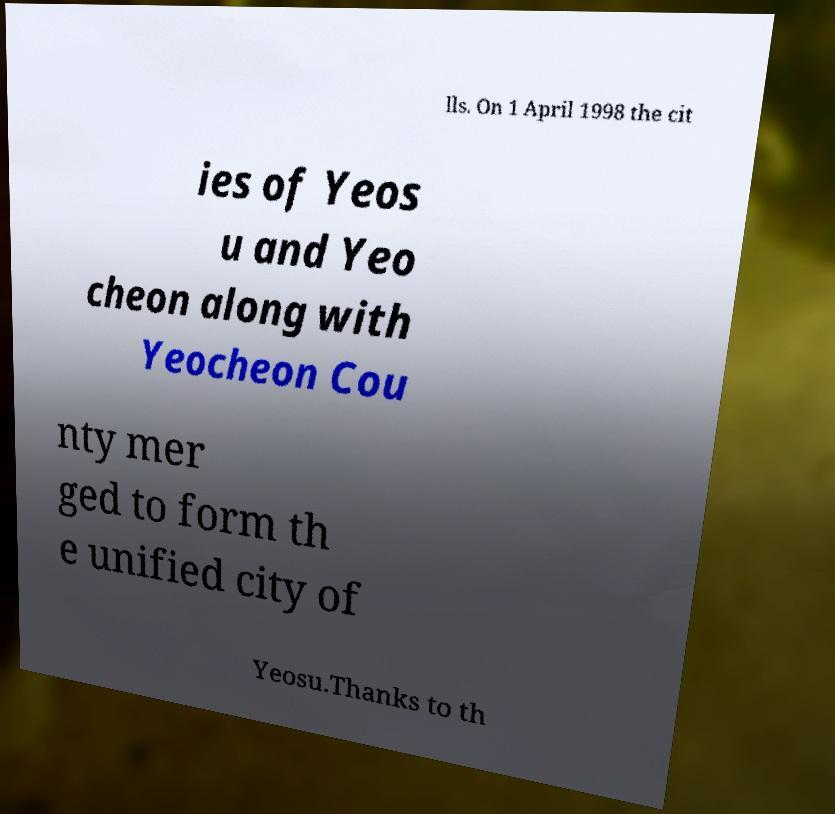For documentation purposes, I need the text within this image transcribed. Could you provide that? lls. On 1 April 1998 the cit ies of Yeos u and Yeo cheon along with Yeocheon Cou nty mer ged to form th e unified city of Yeosu.Thanks to th 